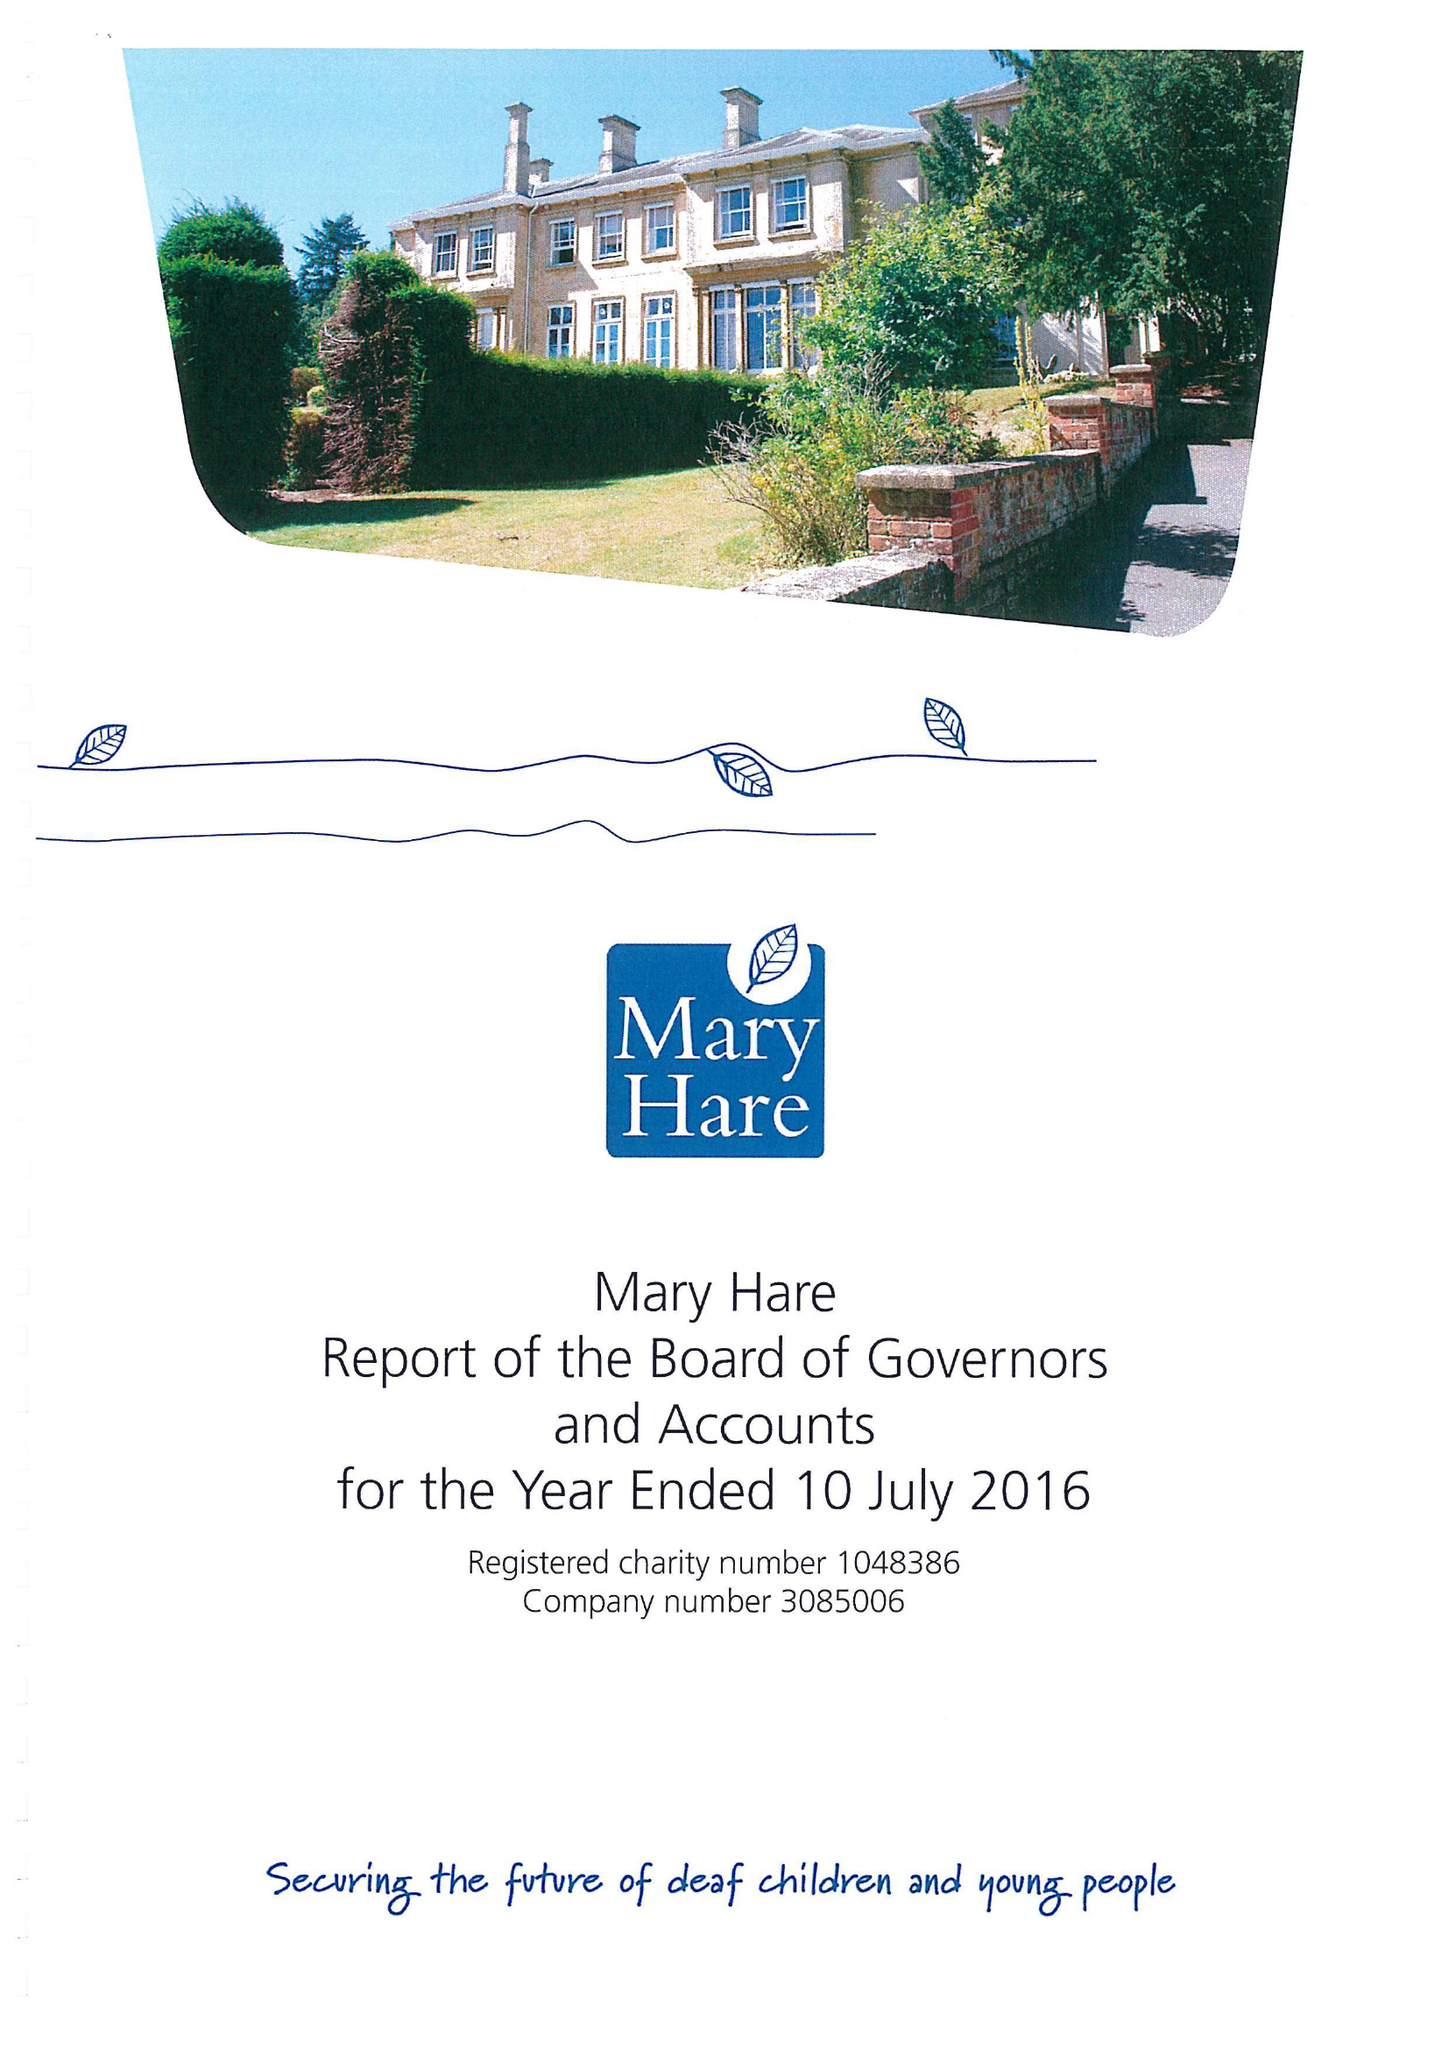What is the value for the income_annually_in_british_pounds?
Answer the question using a single word or phrase. 11008000.00 